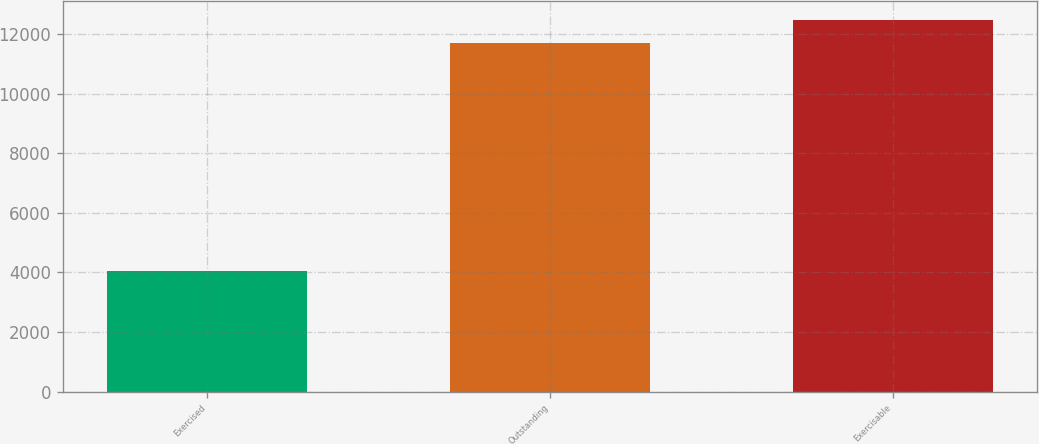Convert chart to OTSL. <chart><loc_0><loc_0><loc_500><loc_500><bar_chart><fcel>Exercised<fcel>Outstanding<fcel>Exercisable<nl><fcel>4051<fcel>11711<fcel>12477<nl></chart> 